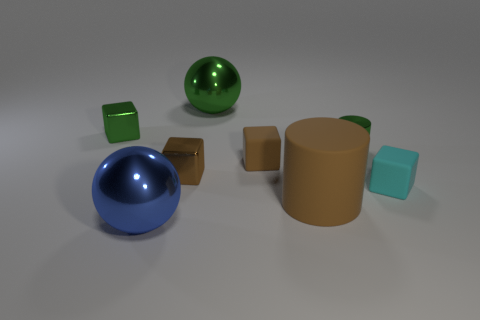Are there an equal number of small cyan rubber objects left of the brown cylinder and brown matte objects that are in front of the large blue ball?
Your answer should be very brief. Yes. What is the material of the small green object that is left of the green shiny cylinder?
Offer a terse response. Metal. What number of things are brown matte objects in front of the small cyan cube or tiny red cubes?
Your answer should be very brief. 1. What number of other objects are there of the same shape as the big brown matte thing?
Offer a very short reply. 1. Do the metal object in front of the cyan object and the small brown metallic object have the same shape?
Your answer should be compact. No. Are there any large brown things behind the tiny brown metal object?
Make the answer very short. No. What number of small objects are either shiny cubes or brown rubber blocks?
Provide a short and direct response. 3. Is the material of the green ball the same as the blue ball?
Give a very brief answer. Yes. There is a matte thing that is the same color as the large matte cylinder; what size is it?
Offer a very short reply. Small. Is there another large rubber cylinder of the same color as the large cylinder?
Provide a succinct answer. No. 